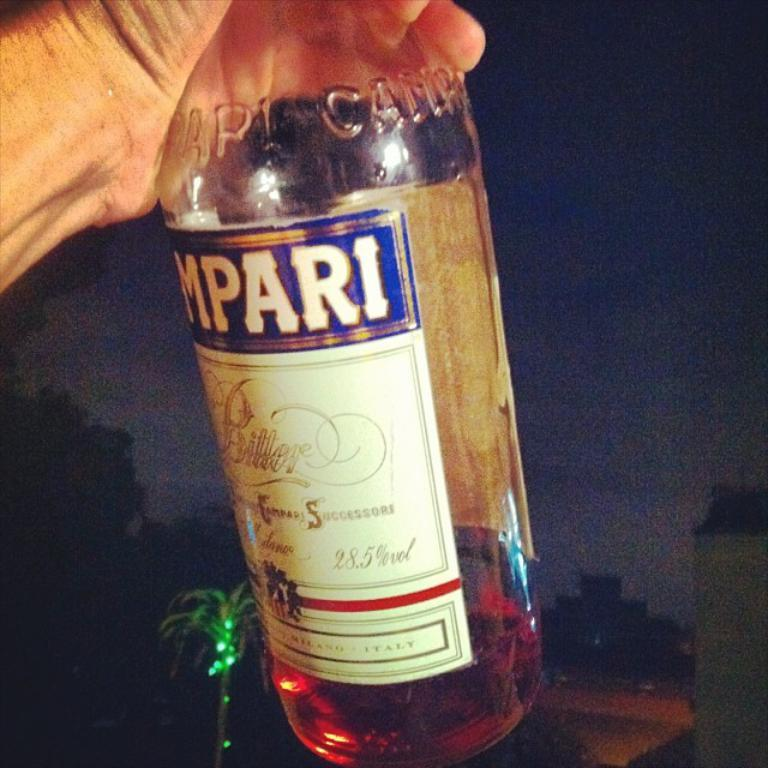<image>
Present a compact description of the photo's key features. A bottle of alcohol which has the letters MPARI visible on the label. 